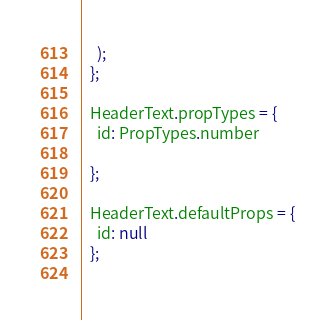Convert code to text. <code><loc_0><loc_0><loc_500><loc_500><_JavaScript_>    );
  };
  
  HeaderText.propTypes = {
    id: PropTypes.number
   
  };
  
  HeaderText.defaultProps = {
    id: null
  };
  </code> 